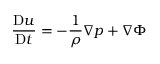<formula> <loc_0><loc_0><loc_500><loc_500>{ \frac { D { u } } { D t } } = - { \frac { 1 } { \rho } } { \nabla } p + { \nabla } \Phi</formula> 